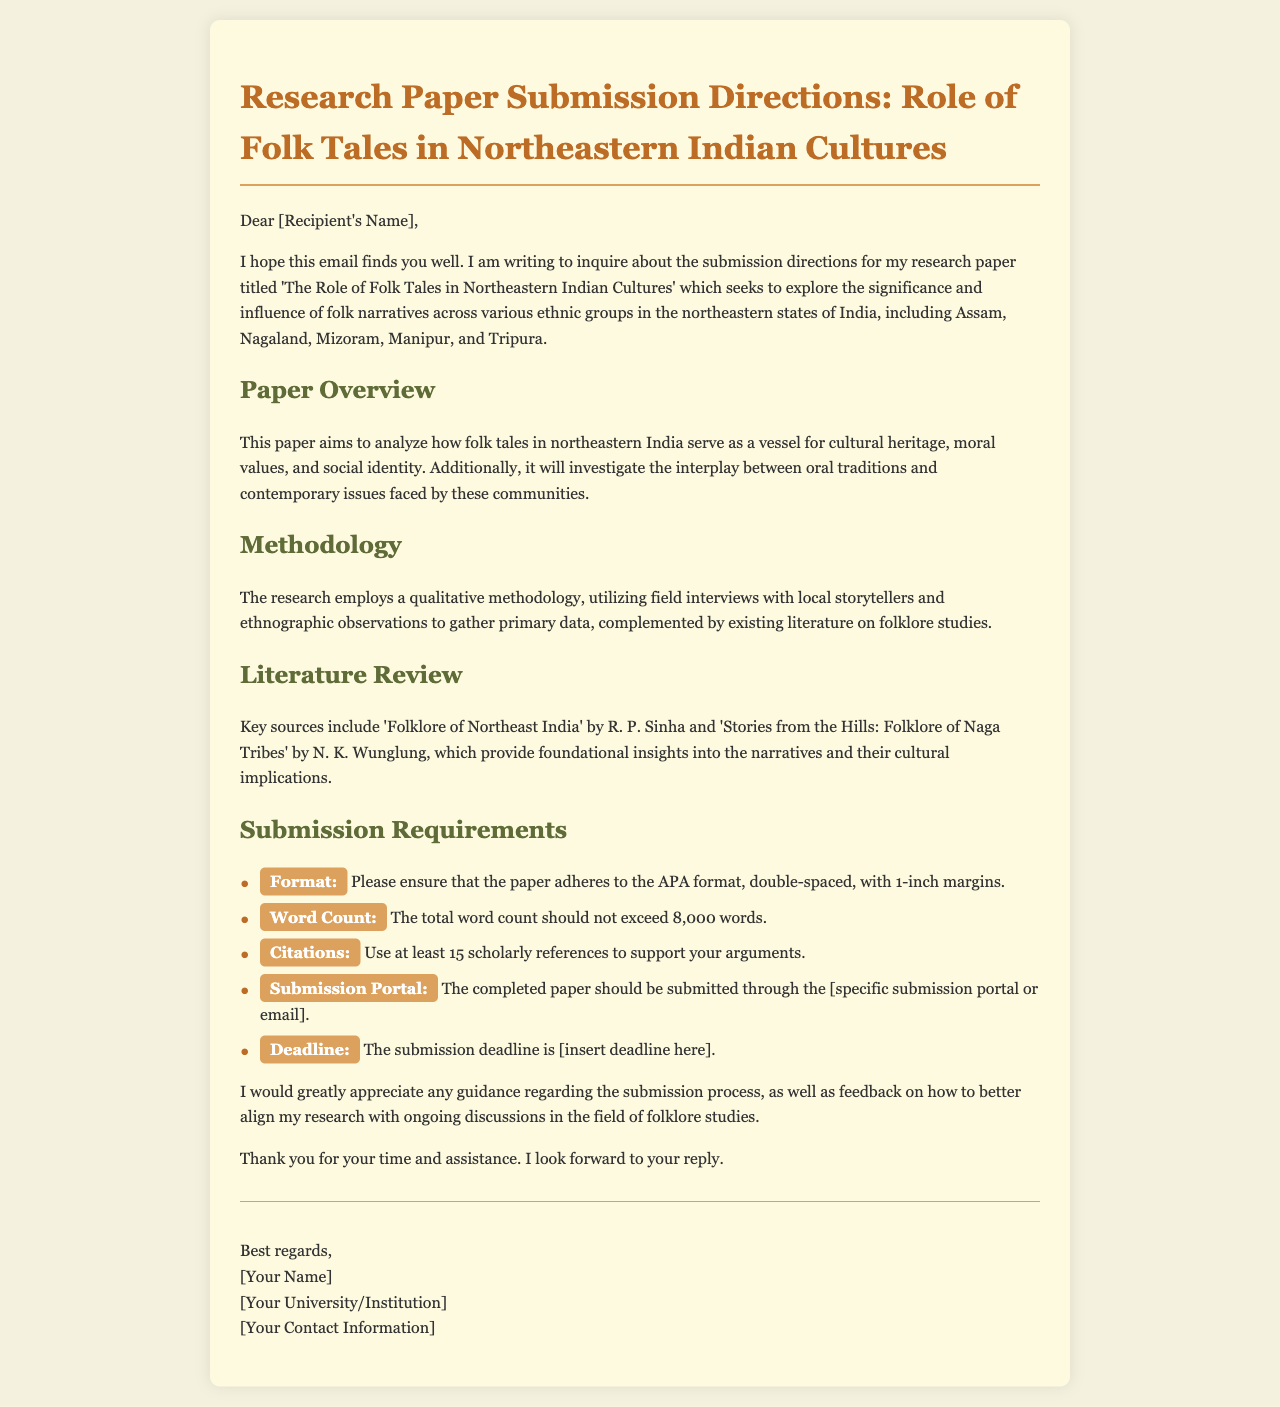What is the title of the research paper? The title of the research paper is mentioned in the introduction paragraph.
Answer: The Role of Folk Tales in Northeastern Indian Cultures What is the maximum word count for the paper? The document specifies the total word count limit for the submission.
Answer: 8,000 words Who are the authors of the key literature sources referenced? The document lists key sources and their authors in the literature review section.
Answer: R. P. Sinha and N. K. Wunglung What method is primarily used in this research? The methodology section describes the primary research method used for this study.
Answer: Qualitative methodology What format should the paper adhere to? The submission requirements include formatting information that needs to be followed.
Answer: APA format What is the submission portal mentioned in the document? The document outlines the means of submitting the completed paper.
Answer: [specific submission portal or email] When is the submission deadline? The document states the deadline for submitting the research paper.
Answer: [insert deadline here] What is the main focus of the research paper? The overview section indicates the primary objective of the research paper.
Answer: Cultural heritage, moral values, and social identity 